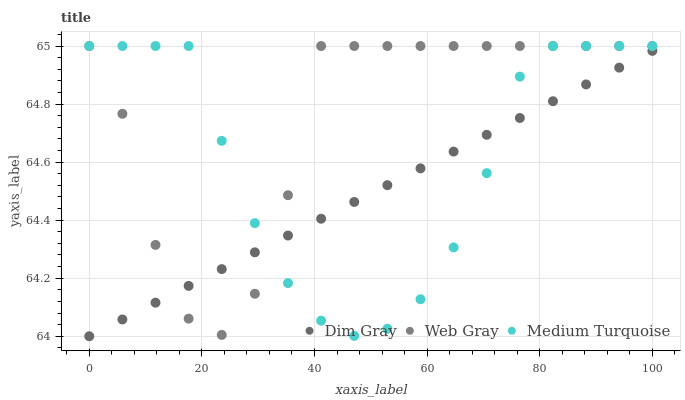Does Dim Gray have the minimum area under the curve?
Answer yes or no. Yes. Does Web Gray have the maximum area under the curve?
Answer yes or no. Yes. Does Medium Turquoise have the minimum area under the curve?
Answer yes or no. No. Does Medium Turquoise have the maximum area under the curve?
Answer yes or no. No. Is Dim Gray the smoothest?
Answer yes or no. Yes. Is Web Gray the roughest?
Answer yes or no. Yes. Is Medium Turquoise the smoothest?
Answer yes or no. No. Is Medium Turquoise the roughest?
Answer yes or no. No. Does Dim Gray have the lowest value?
Answer yes or no. Yes. Does Medium Turquoise have the lowest value?
Answer yes or no. No. Does Medium Turquoise have the highest value?
Answer yes or no. Yes. Does Web Gray intersect Medium Turquoise?
Answer yes or no. Yes. Is Web Gray less than Medium Turquoise?
Answer yes or no. No. Is Web Gray greater than Medium Turquoise?
Answer yes or no. No. 